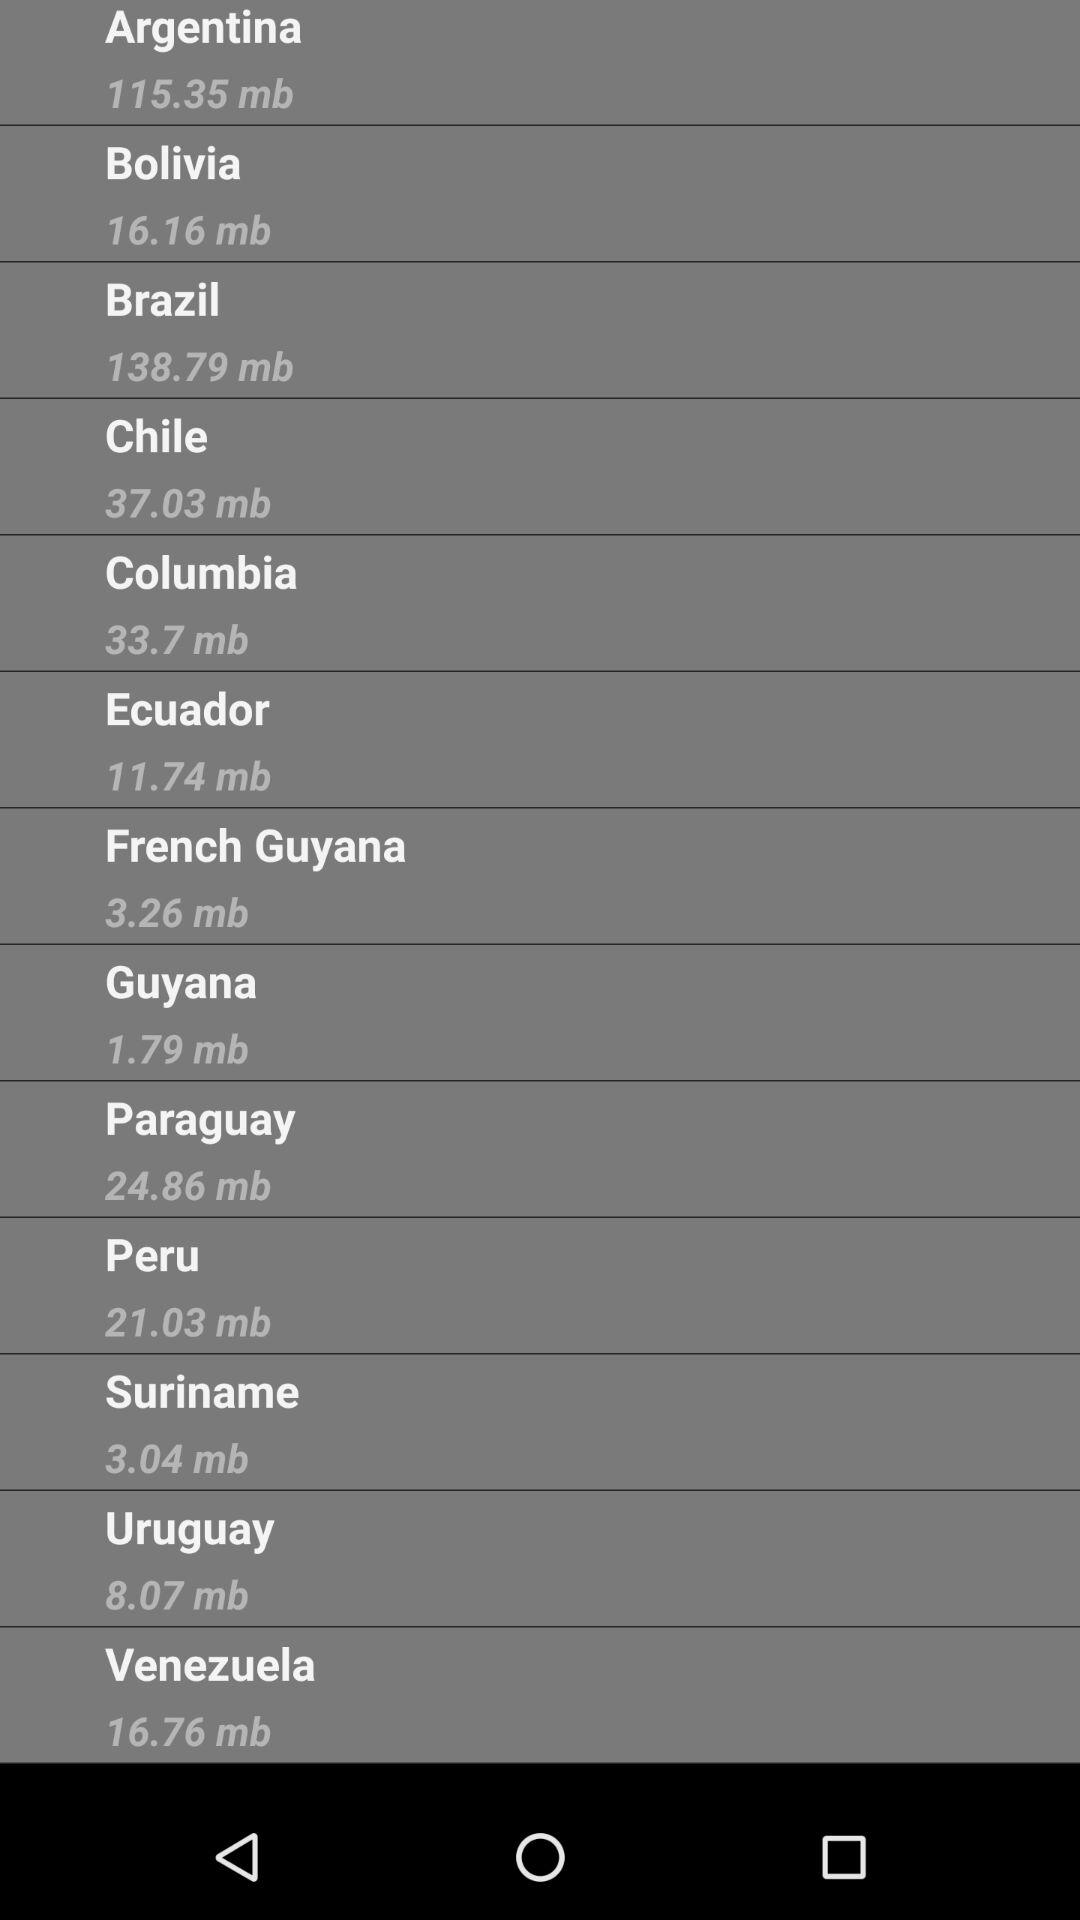What is the file size of "Chile"? The file size is 37.03 megabytes. 